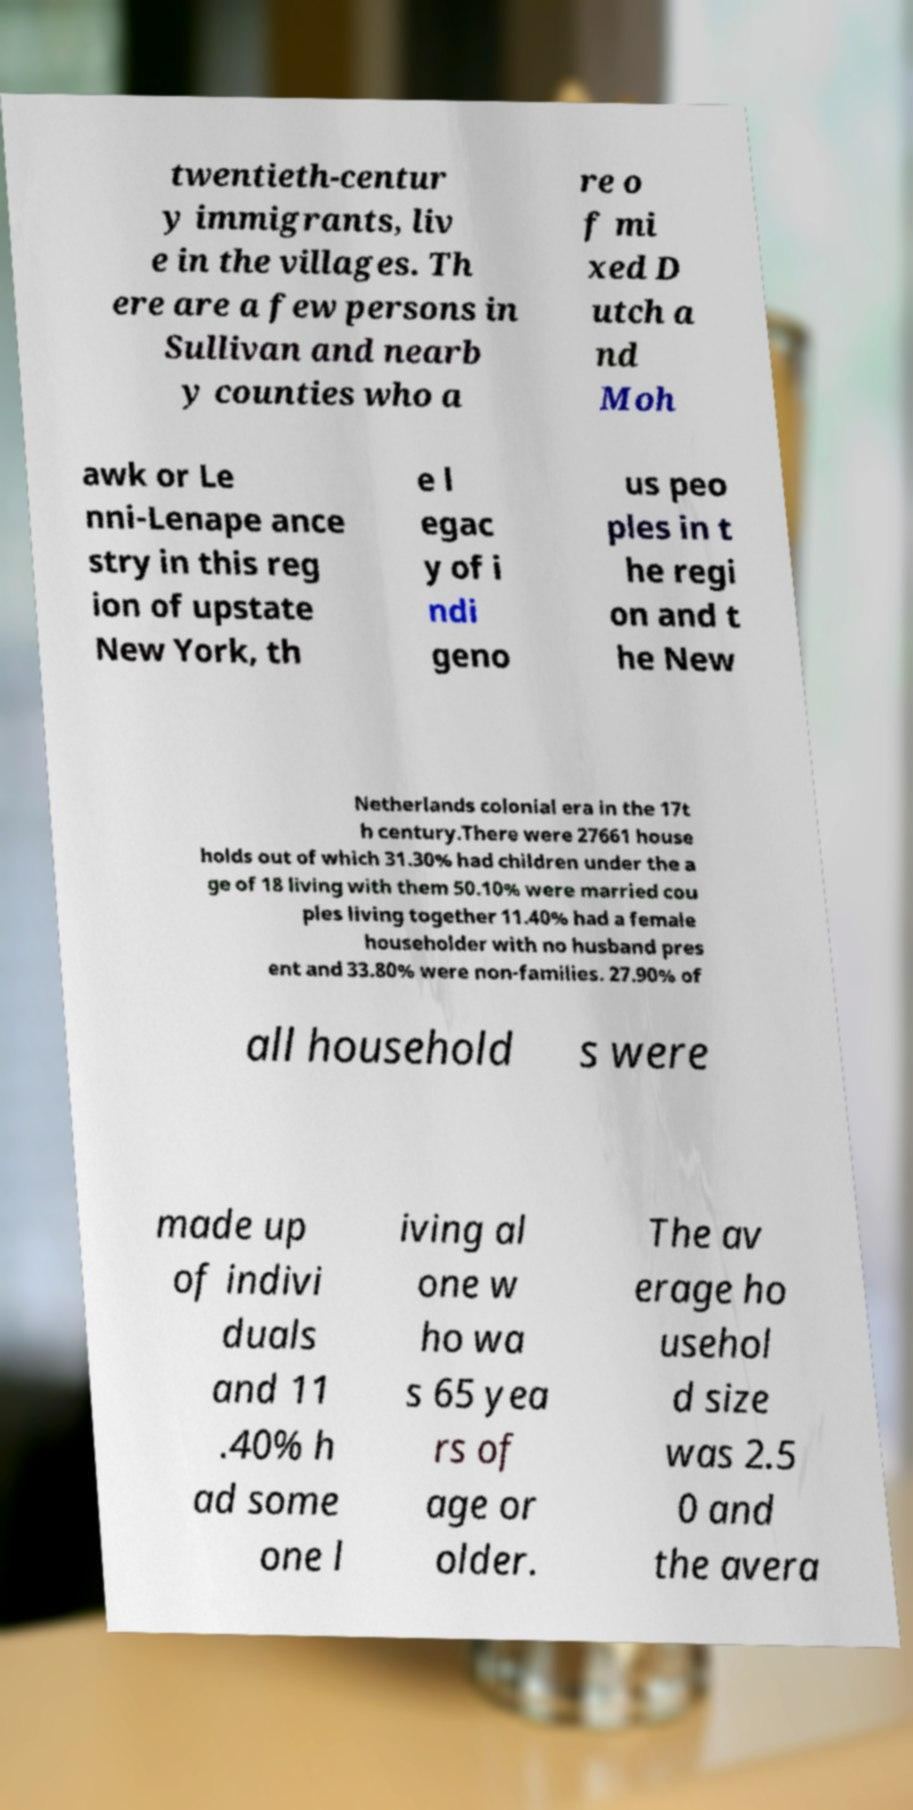For documentation purposes, I need the text within this image transcribed. Could you provide that? twentieth-centur y immigrants, liv e in the villages. Th ere are a few persons in Sullivan and nearb y counties who a re o f mi xed D utch a nd Moh awk or Le nni-Lenape ance stry in this reg ion of upstate New York, th e l egac y of i ndi geno us peo ples in t he regi on and t he New Netherlands colonial era in the 17t h century.There were 27661 house holds out of which 31.30% had children under the a ge of 18 living with them 50.10% were married cou ples living together 11.40% had a female householder with no husband pres ent and 33.80% were non-families. 27.90% of all household s were made up of indivi duals and 11 .40% h ad some one l iving al one w ho wa s 65 yea rs of age or older. The av erage ho usehol d size was 2.5 0 and the avera 